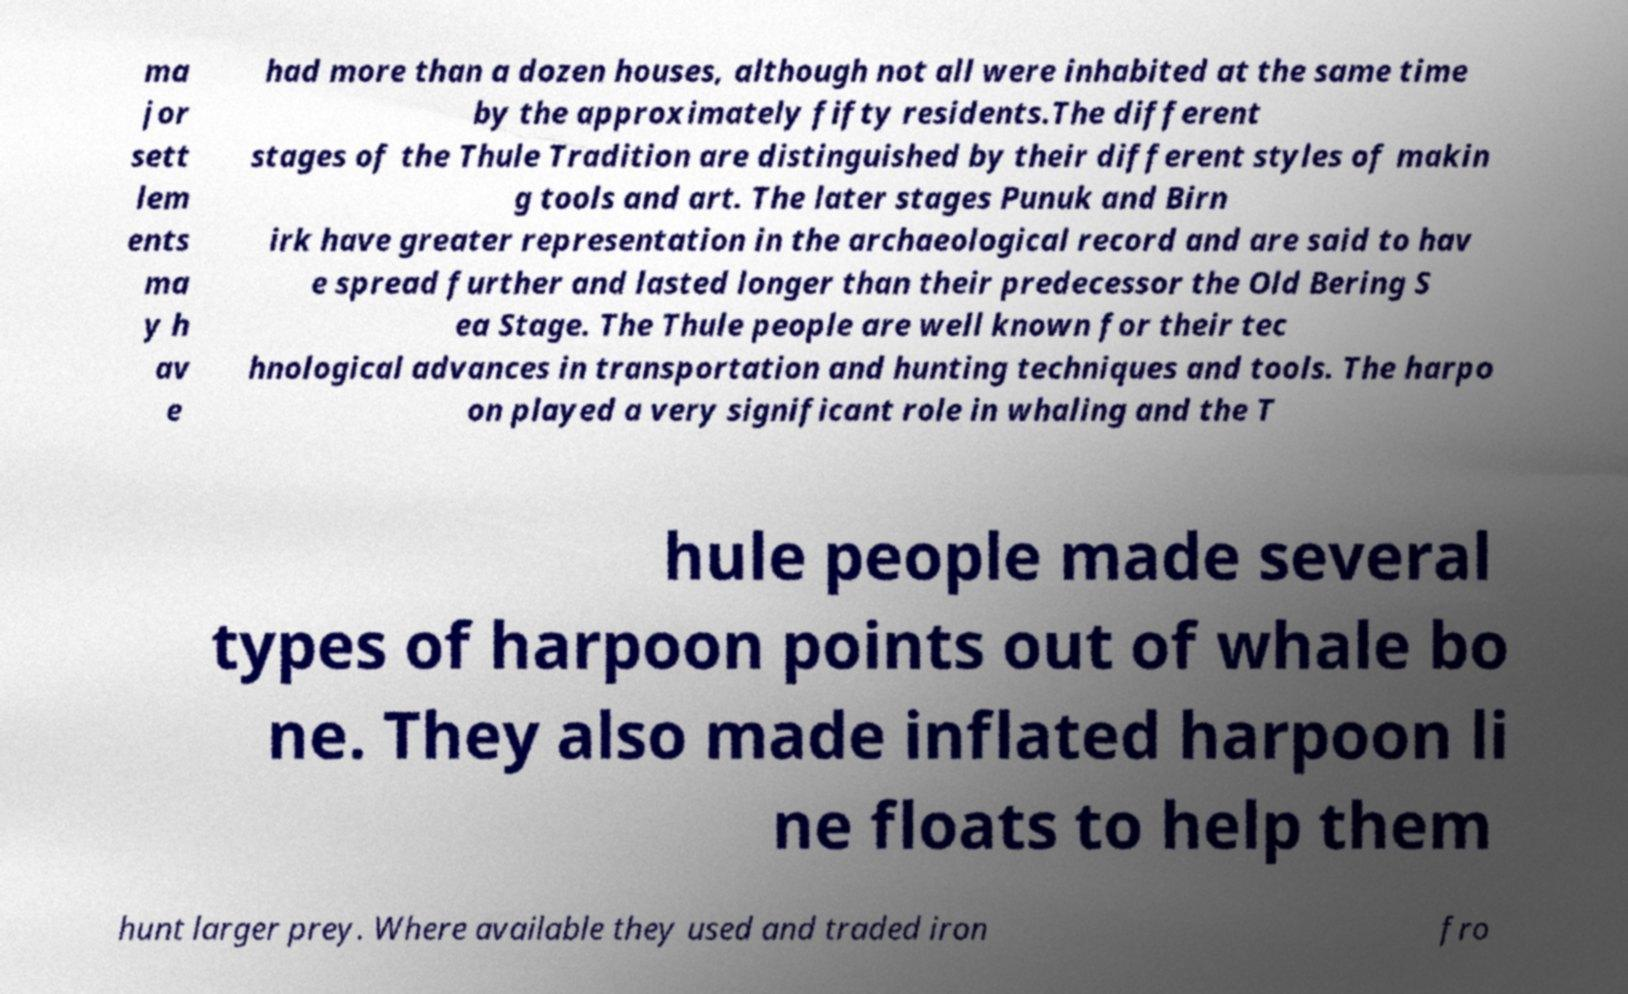Could you extract and type out the text from this image? ma jor sett lem ents ma y h av e had more than a dozen houses, although not all were inhabited at the same time by the approximately fifty residents.The different stages of the Thule Tradition are distinguished by their different styles of makin g tools and art. The later stages Punuk and Birn irk have greater representation in the archaeological record and are said to hav e spread further and lasted longer than their predecessor the Old Bering S ea Stage. The Thule people are well known for their tec hnological advances in transportation and hunting techniques and tools. The harpo on played a very significant role in whaling and the T hule people made several types of harpoon points out of whale bo ne. They also made inflated harpoon li ne floats to help them hunt larger prey. Where available they used and traded iron fro 